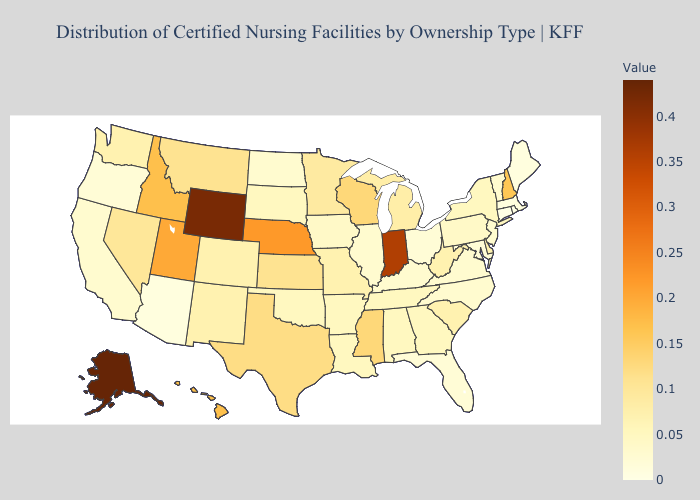Among the states that border Missouri , does Nebraska have the highest value?
Be succinct. Yes. Among the states that border Arkansas , does Tennessee have the highest value?
Write a very short answer. No. Which states have the lowest value in the MidWest?
Write a very short answer. Ohio. Among the states that border Iowa , which have the highest value?
Give a very brief answer. Nebraska. Does Oklahoma have the highest value in the South?
Be succinct. No. 